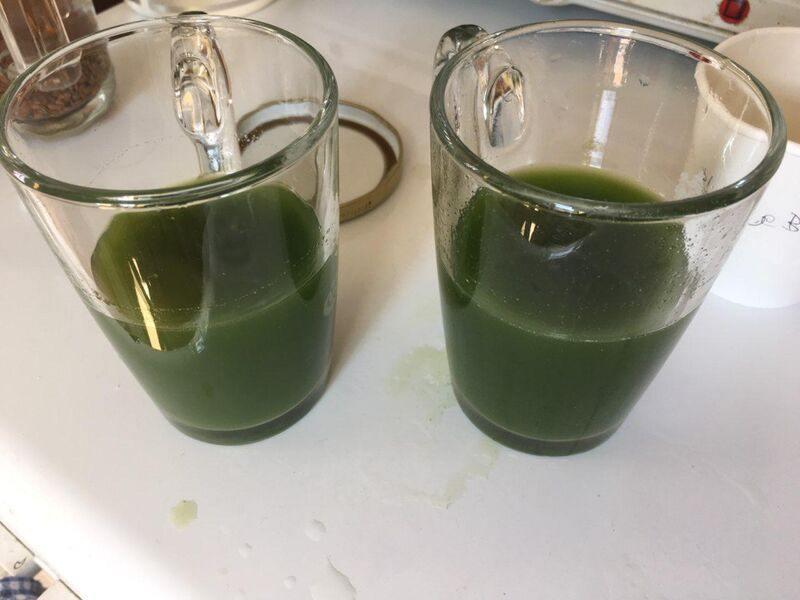Does the presence of the spillage suggest anything about the person's habits? The spillage might suggest that the person is either in a hurry or generally a bit clumsy with kitchen tasks. It could also imply that they're not overly concerned with minor messes, focusing more on the task at hand. Alternatively, if this is a one-time occurrence, it might simply indicate that they were distracted or inexperienced with pouring liquids into these specific mugs. What precautionary steps can be taken to avoid such spillage in future? To prevent spillage in the future, a few precautionary steps can be taken: 
1. Use a container with a spout to pour the liquid. 
2. Focus on pouring slowly and steadily. 
3. Ensure the mugs are stable and placed on a flat surface. 
4. Consider using a funnel to guide the liquid into the mugs. 
5. Pay attention to the liquid levels to stop before reaching the brim, leaving some space to avoid overflow. 
Taking these steps can help in making the pouring process neater and more controlled. Can you paint a picture of a realistic scenario where such a spillage happens daily? A realistic scenario where such spillage happens daily could be a busy family kitchen in the morning. Picture a parent trying to prepare breakfast and smoothies for the family while managing to get everyone ready for the day. In the hustle and bustle, small spills are inevitable - perhaps the parent is pouring smoothies while keeping an eye on the children eating their breakfast or getting ready for school. The rush and multitasking often lead to little accidents like this spillage, which are quickly cleaned up as part of their daily routine. Imagine an alternate universe explanation for the continuous spillage. In an alternate universe, the constant spillage could be due to a mischievous household spirit or sprite that delights in creating minor chaos. Every time someone tries to pour a drink, the sprite gives a little nudge, causing the liquid to splash out. The inhabitants of this universe have learned to coexist with the sprite's antics, often leaving small offerings of treats to appease it and reduce the frequency of its pranks. Occasionally, the spirit even helps by cleaning up some of the spills it causes, as a playful way of maintaining balance. 